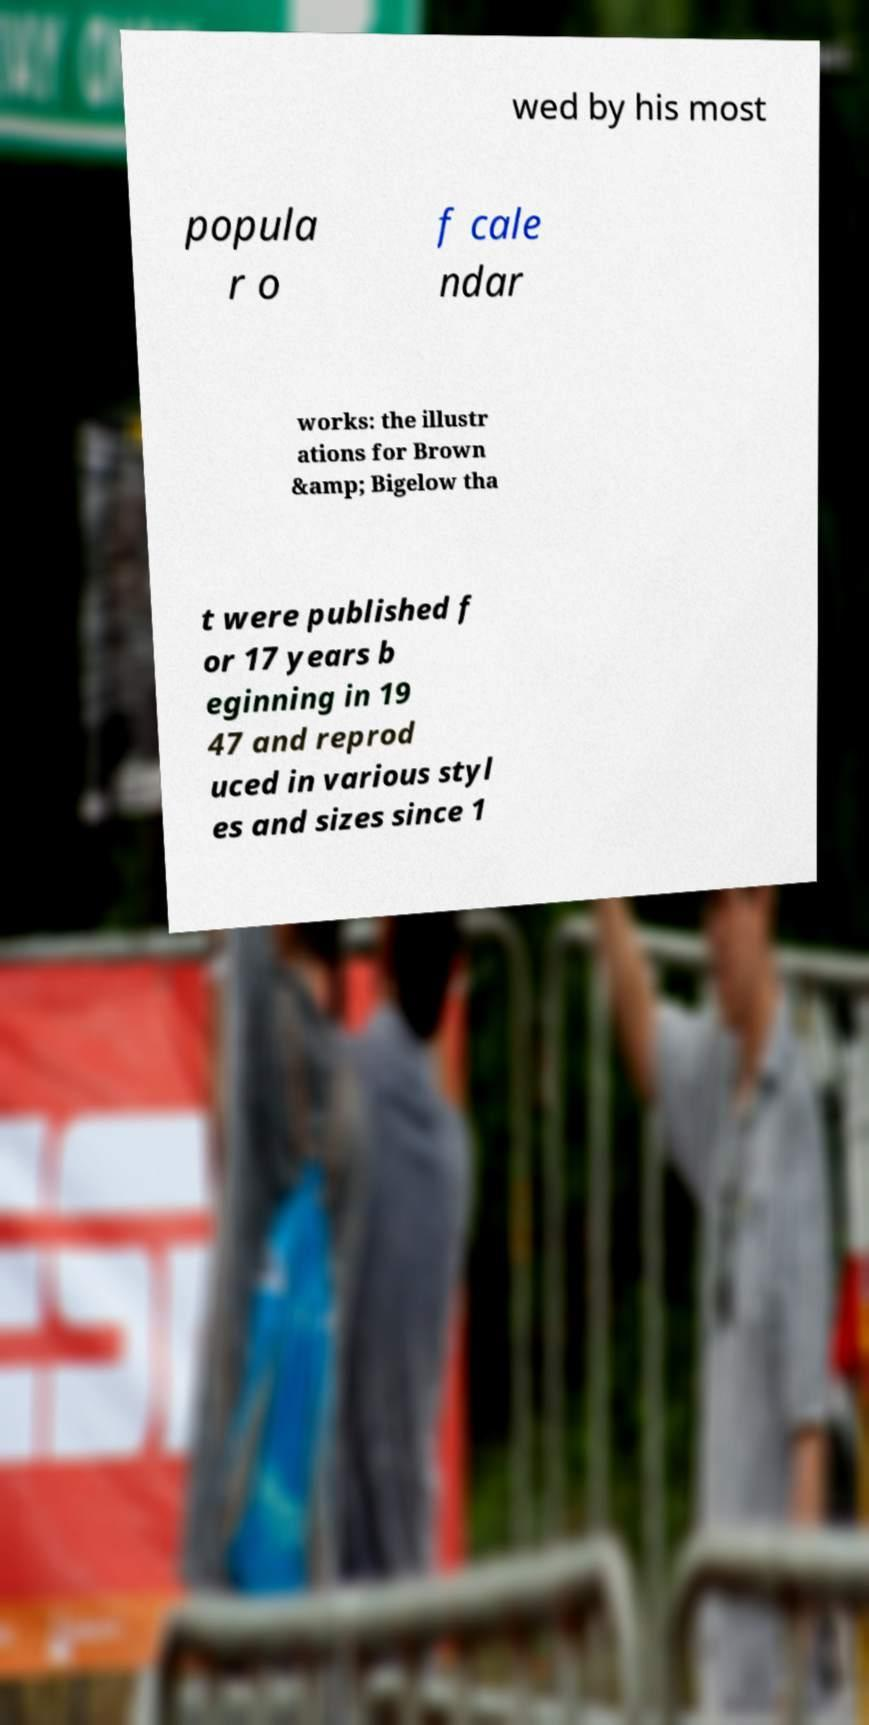I need the written content from this picture converted into text. Can you do that? wed by his most popula r o f cale ndar works: the illustr ations for Brown &amp; Bigelow tha t were published f or 17 years b eginning in 19 47 and reprod uced in various styl es and sizes since 1 